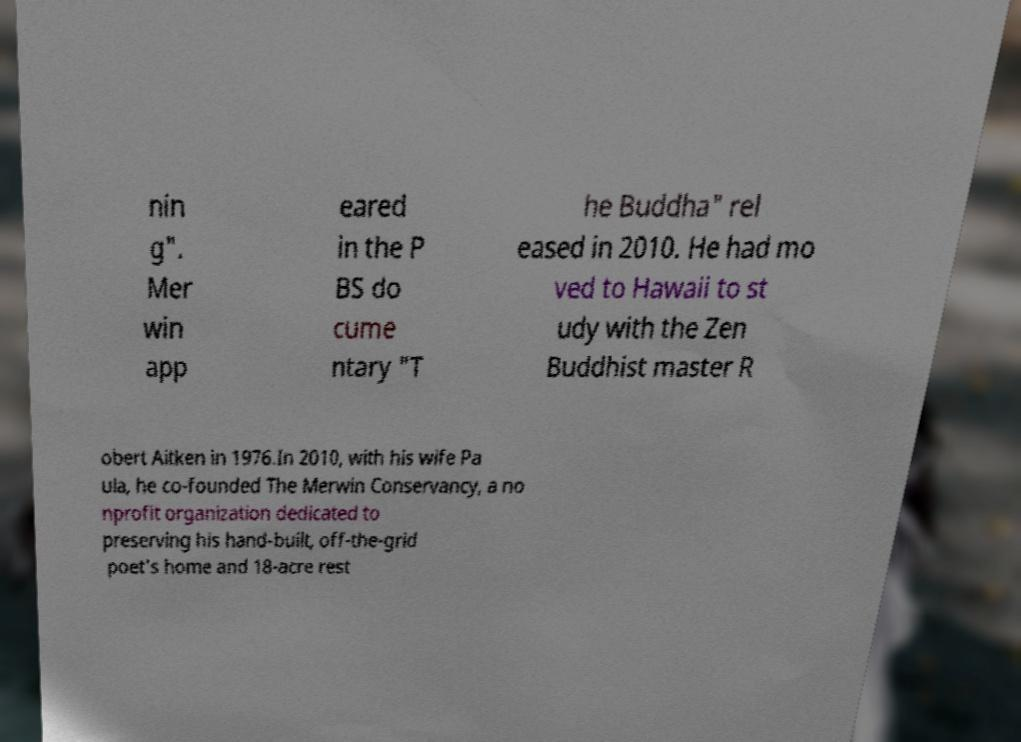There's text embedded in this image that I need extracted. Can you transcribe it verbatim? nin g". Mer win app eared in the P BS do cume ntary "T he Buddha" rel eased in 2010. He had mo ved to Hawaii to st udy with the Zen Buddhist master R obert Aitken in 1976.In 2010, with his wife Pa ula, he co-founded The Merwin Conservancy, a no nprofit organization dedicated to preserving his hand-built, off-the-grid poet's home and 18-acre rest 